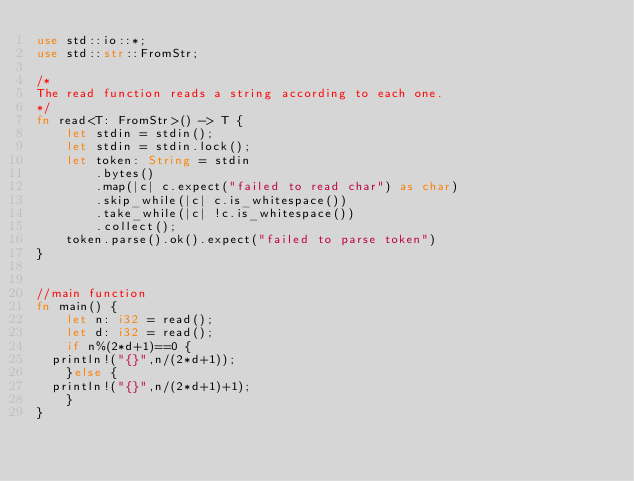<code> <loc_0><loc_0><loc_500><loc_500><_Rust_>use std::io::*;
use std::str::FromStr;
 
/* 
The read function reads a string according to each one. 
*/
fn read<T: FromStr>() -> T {
    let stdin = stdin();
    let stdin = stdin.lock();
    let token: String = stdin
        .bytes()
        .map(|c| c.expect("failed to read char") as char) 
        .skip_while(|c| c.is_whitespace())
        .take_while(|c| !c.is_whitespace())
        .collect();
    token.parse().ok().expect("failed to parse token")
}


//main function
fn main() {
    let n: i32 = read();
    let d: i32 = read();
    if n%(2*d+1)==0 {
	println!("{}",n/(2*d+1));
    }else {
	println!("{}",n/(2*d+1)+1);
    }
}
</code> 